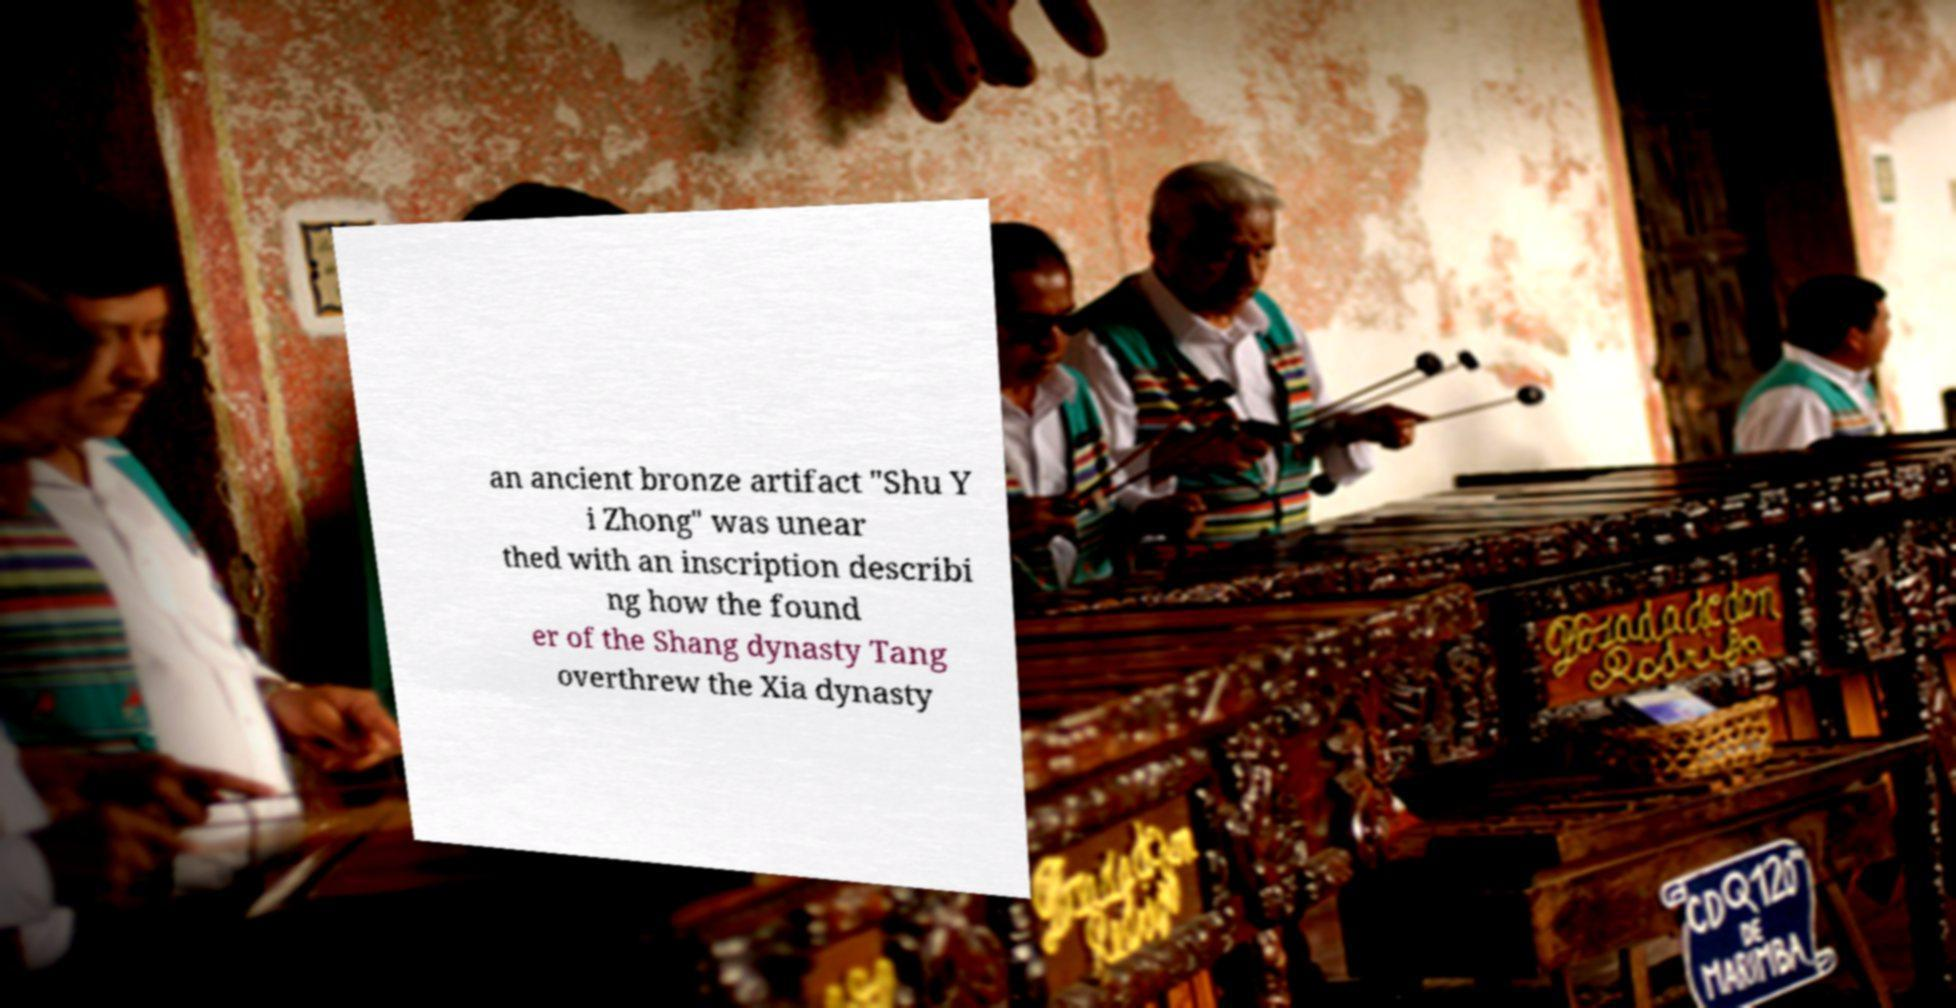What messages or text are displayed in this image? I need them in a readable, typed format. an ancient bronze artifact "Shu Y i Zhong" was unear thed with an inscription describi ng how the found er of the Shang dynasty Tang overthrew the Xia dynasty 